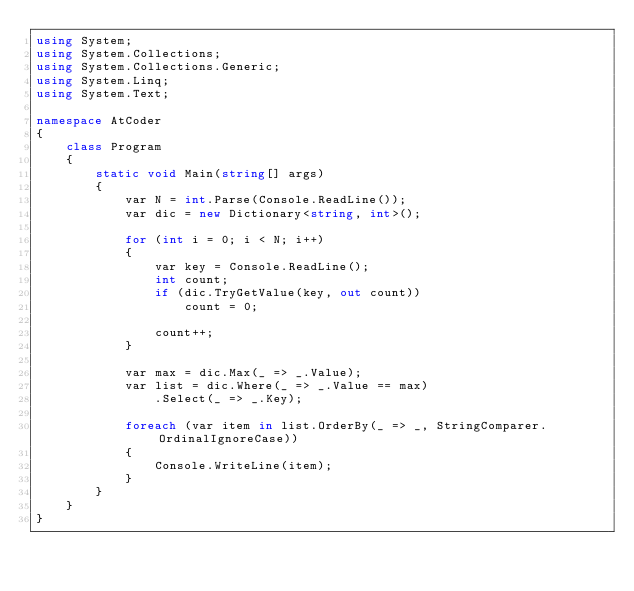<code> <loc_0><loc_0><loc_500><loc_500><_C#_>using System;
using System.Collections;
using System.Collections.Generic;
using System.Linq;
using System.Text;

namespace AtCoder
{
    class Program
    {
        static void Main(string[] args)
        {
            var N = int.Parse(Console.ReadLine());
            var dic = new Dictionary<string, int>();

            for (int i = 0; i < N; i++)
            {
                var key = Console.ReadLine();
                int count;
                if (dic.TryGetValue(key, out count))
                    count = 0;

                count++;
            }

            var max = dic.Max(_ => _.Value);
            var list = dic.Where(_ => _.Value == max)
                .Select(_ => _.Key);

            foreach (var item in list.OrderBy(_ => _, StringComparer.OrdinalIgnoreCase))
            {
                Console.WriteLine(item);
            }
        }
    }
}
</code> 